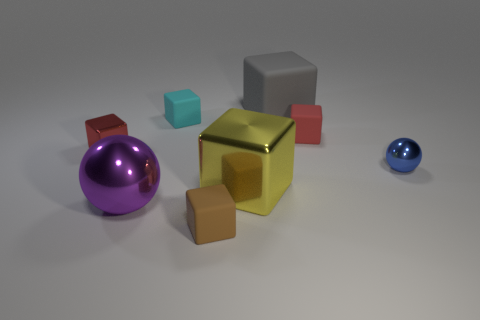There is a tiny matte cube to the right of the gray rubber thing; does it have the same color as the tiny metal block?
Make the answer very short. Yes. How many objects are small red things that are behind the small red metal thing or red cubes?
Your answer should be compact. 2. Are there more tiny metallic objects to the right of the gray thing than large yellow metallic cubes in front of the tiny brown thing?
Your answer should be very brief. Yes. Are the large yellow cube and the big gray thing made of the same material?
Ensure brevity in your answer.  No. What shape is the matte object that is behind the large purple shiny object and in front of the cyan thing?
Your answer should be compact. Cube. There is a blue object that is the same material as the big purple sphere; what shape is it?
Provide a succinct answer. Sphere. Are any small metallic things visible?
Your answer should be compact. Yes. There is a large object behind the small metal cube; is there a small shiny object that is to the right of it?
Offer a very short reply. Yes. What is the material of the big yellow object that is the same shape as the tiny cyan thing?
Provide a succinct answer. Metal. Is the number of yellow cubes greater than the number of big yellow cylinders?
Give a very brief answer. Yes. 